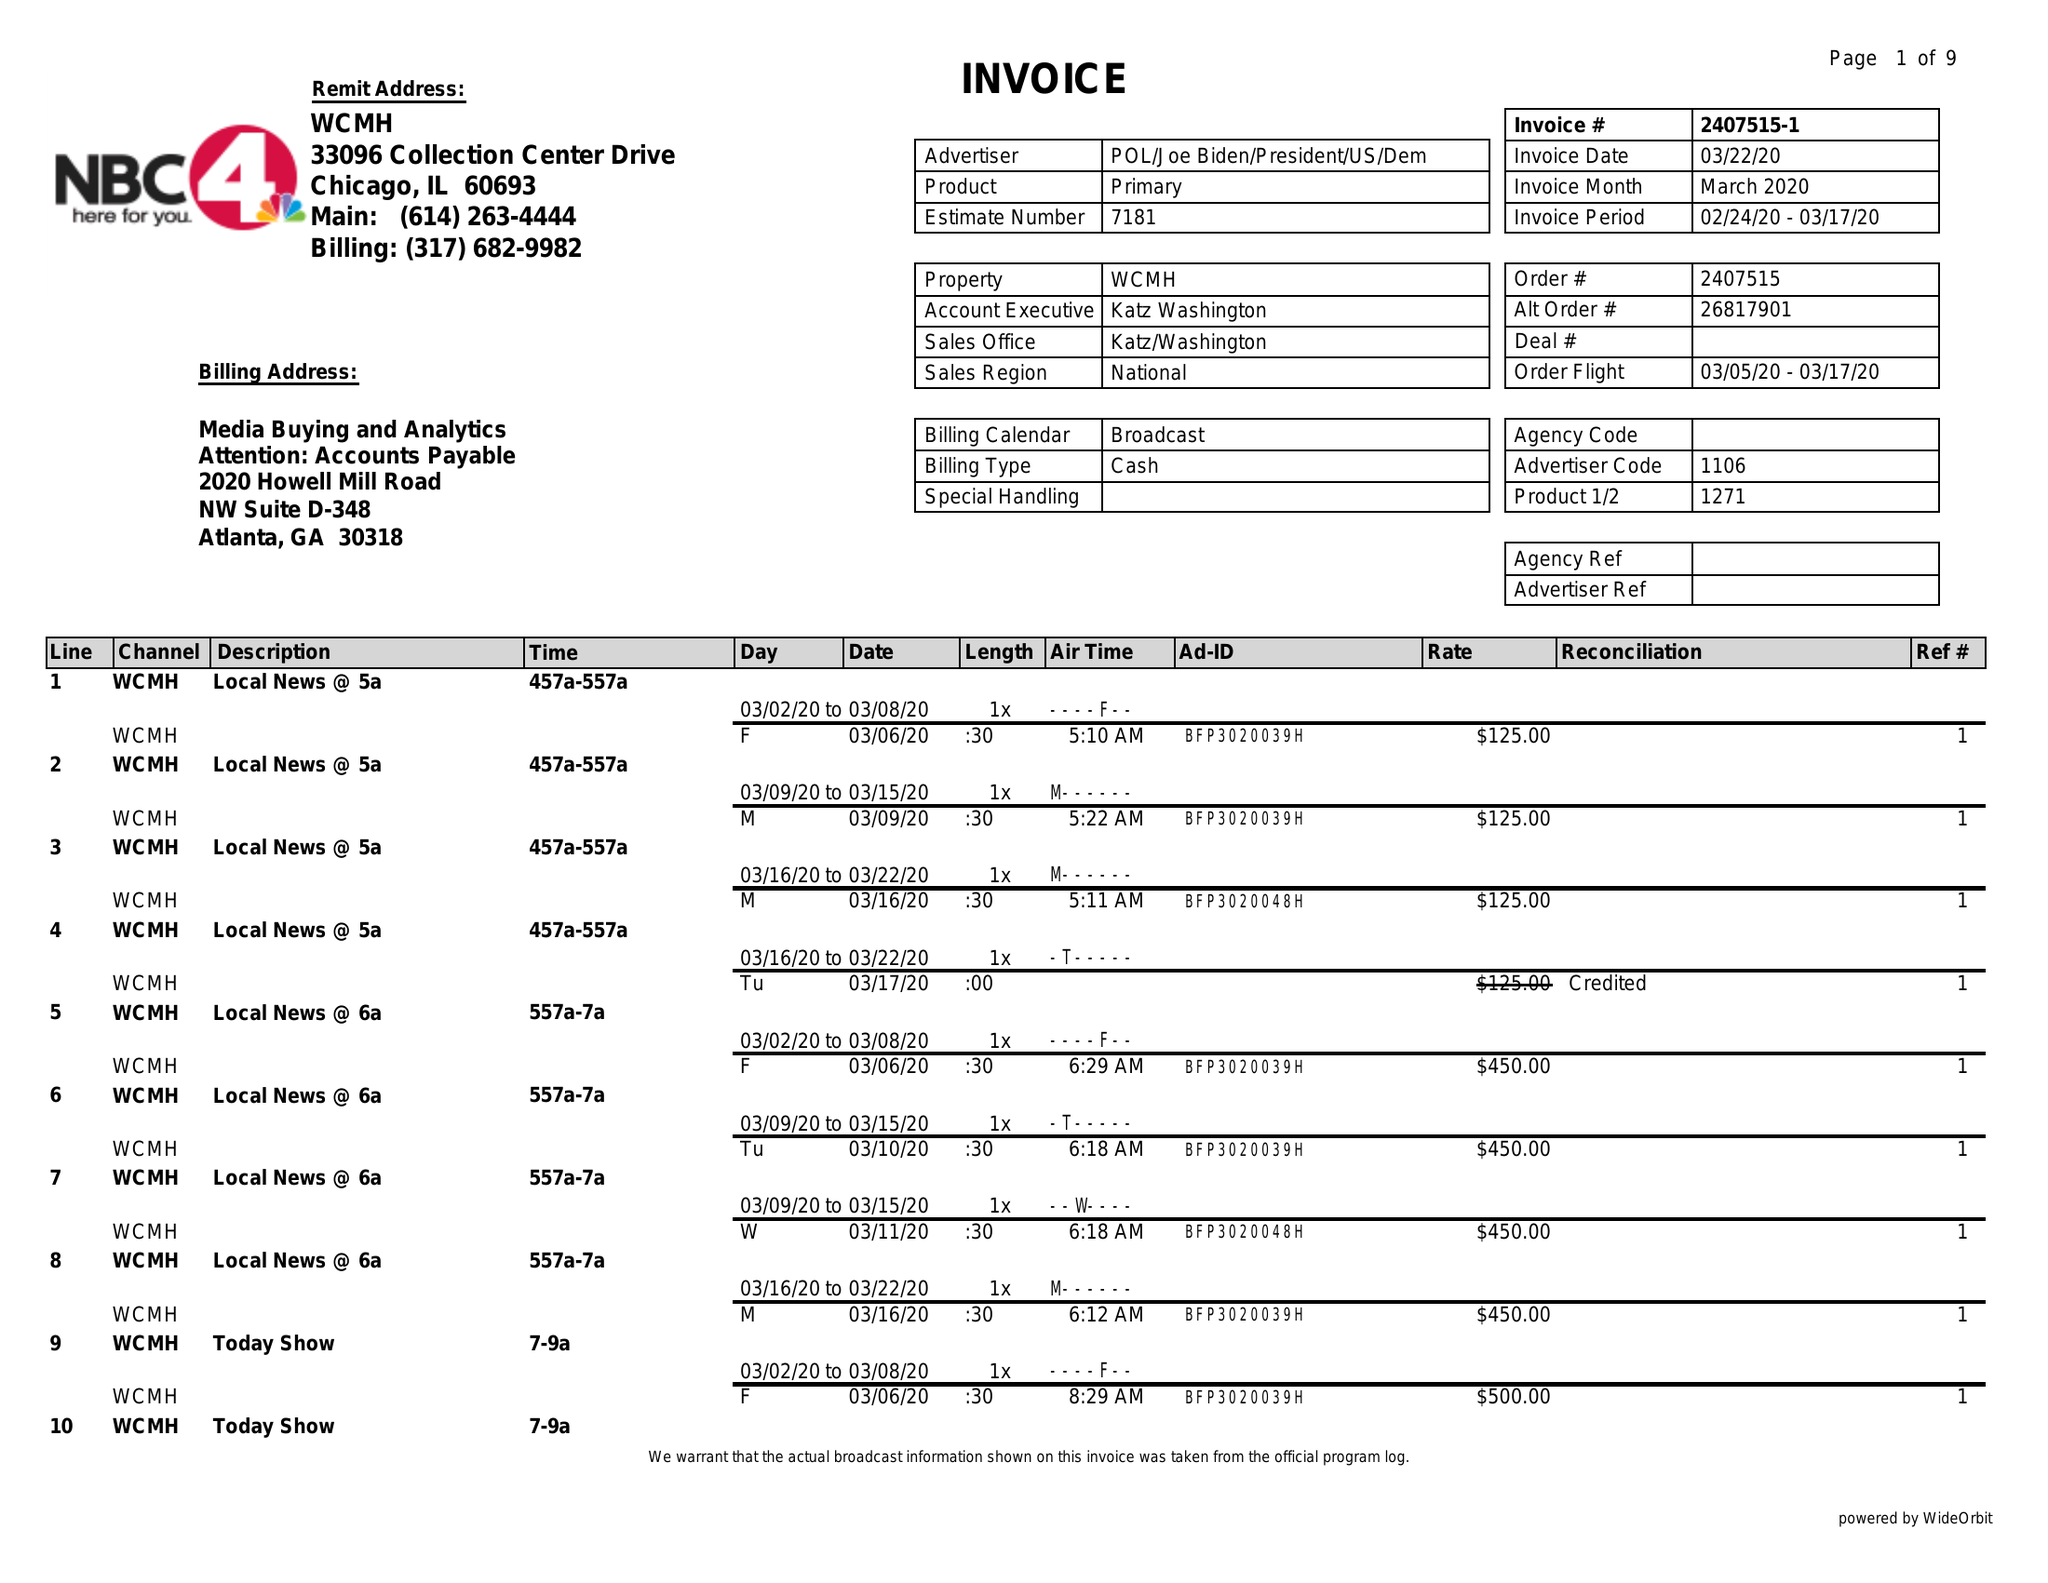What is the value for the contract_num?
Answer the question using a single word or phrase. 2407515 